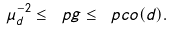Convert formula to latex. <formula><loc_0><loc_0><loc_500><loc_500>\mu _ { d } ^ { - 2 } \leq \ p g \leq \ p c o ( d ) .</formula> 